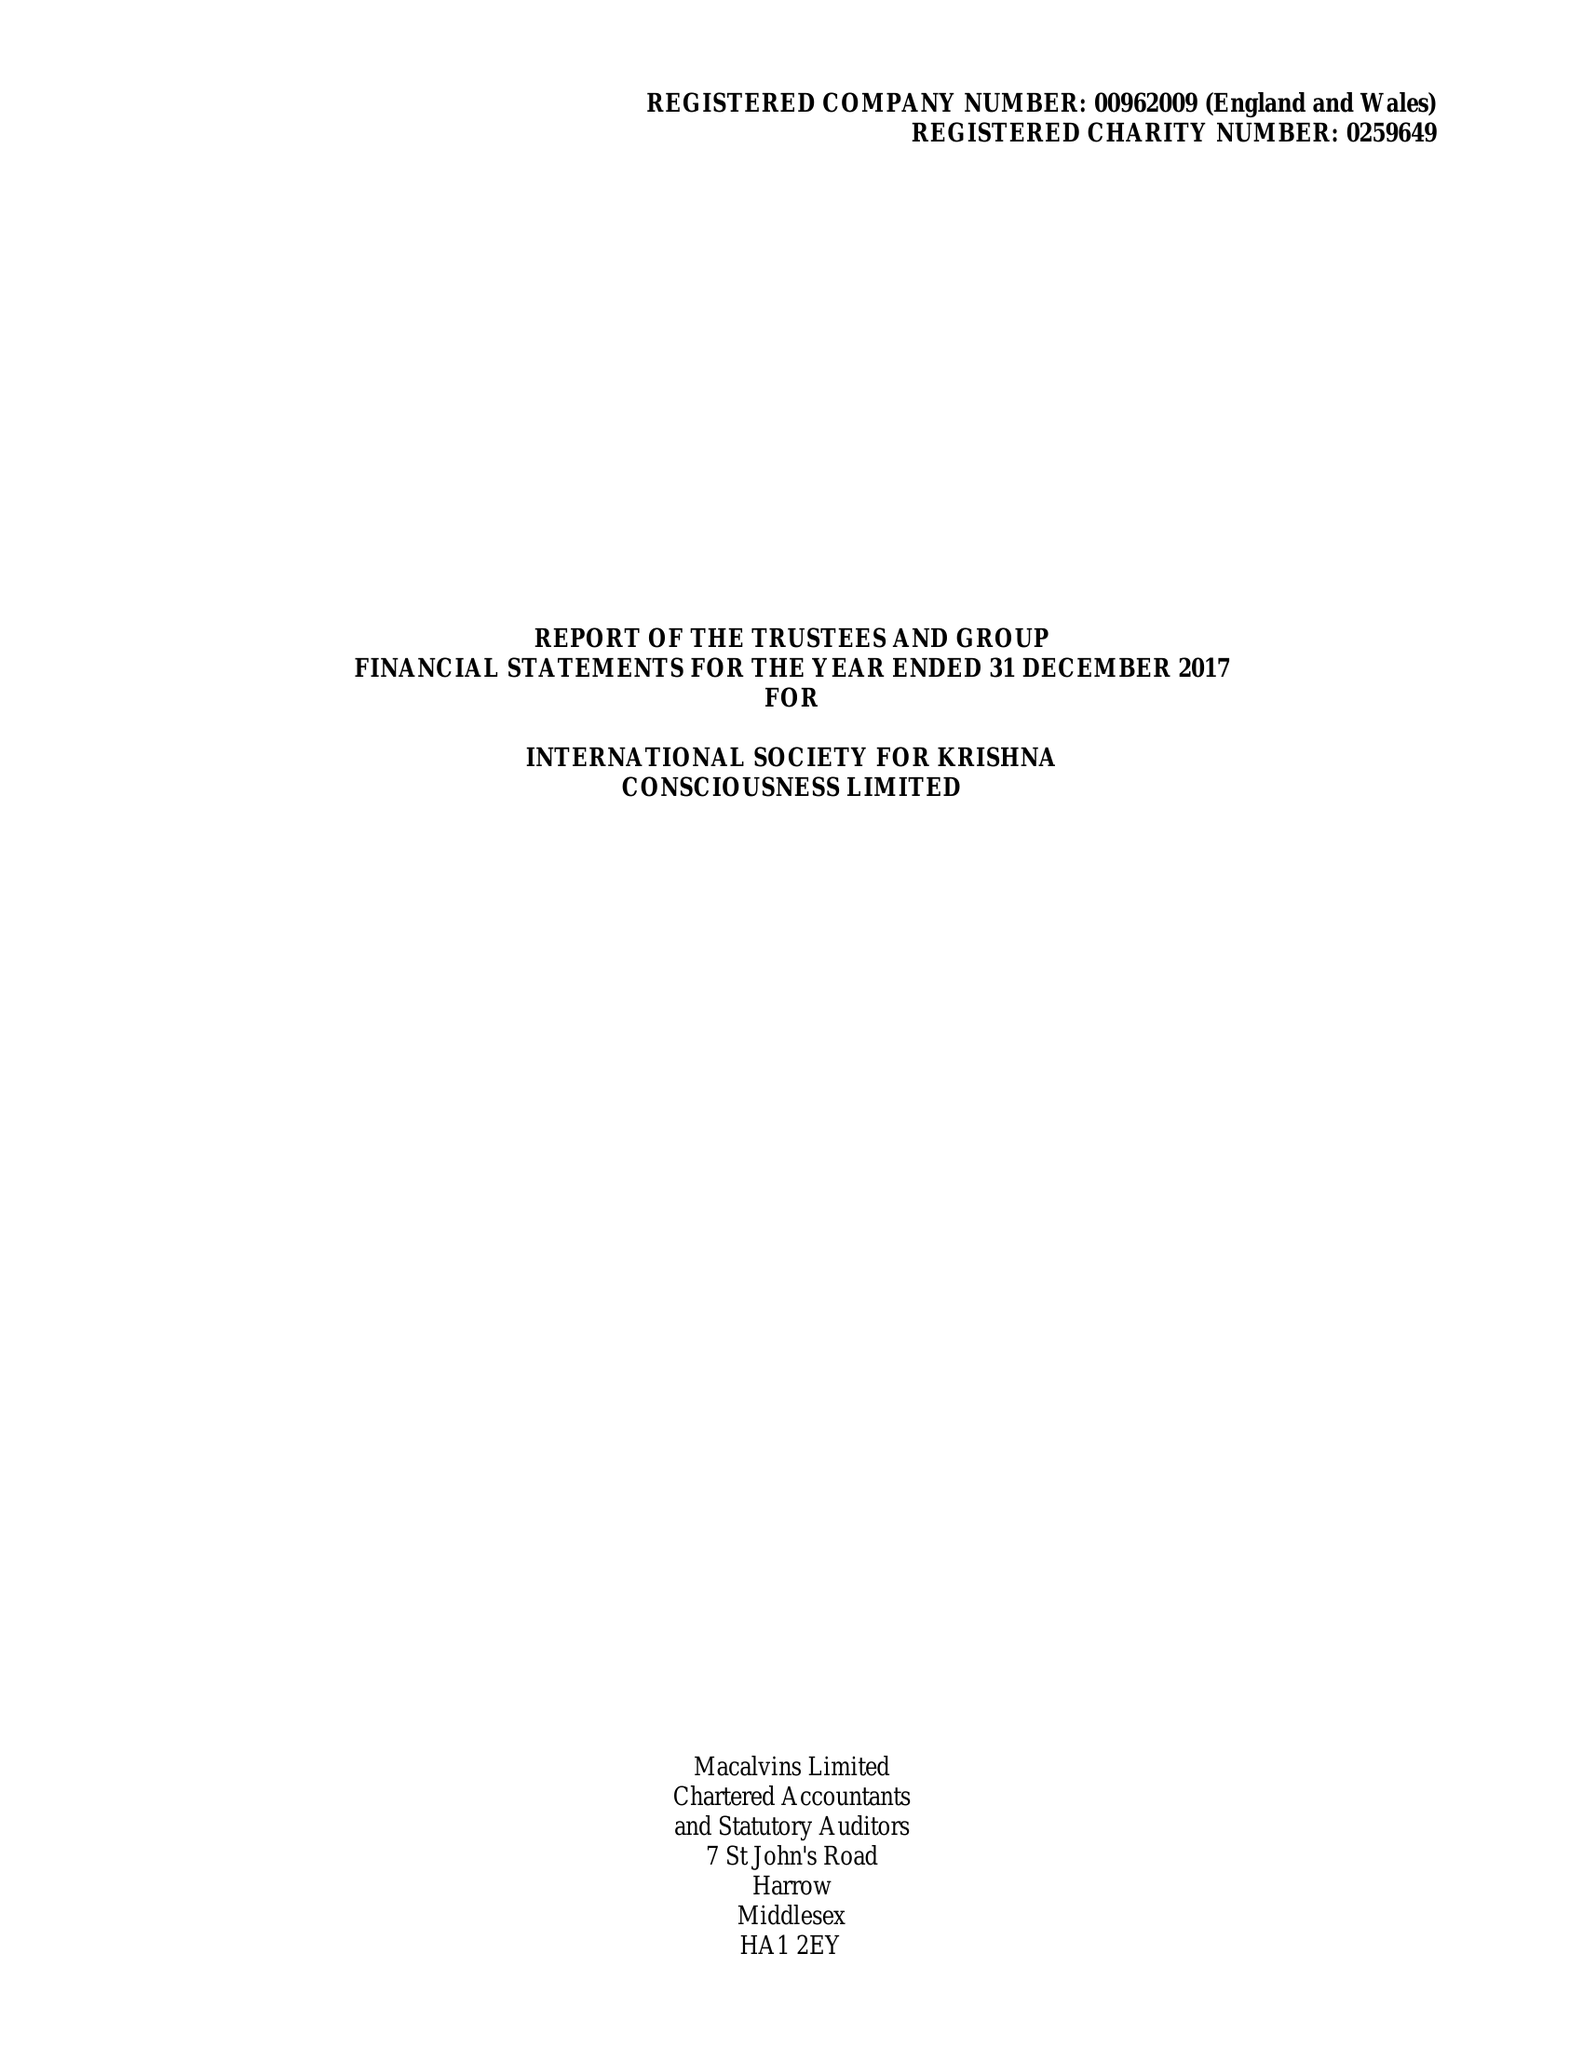What is the value for the address__postcode?
Answer the question using a single word or phrase. WD7 8LA 